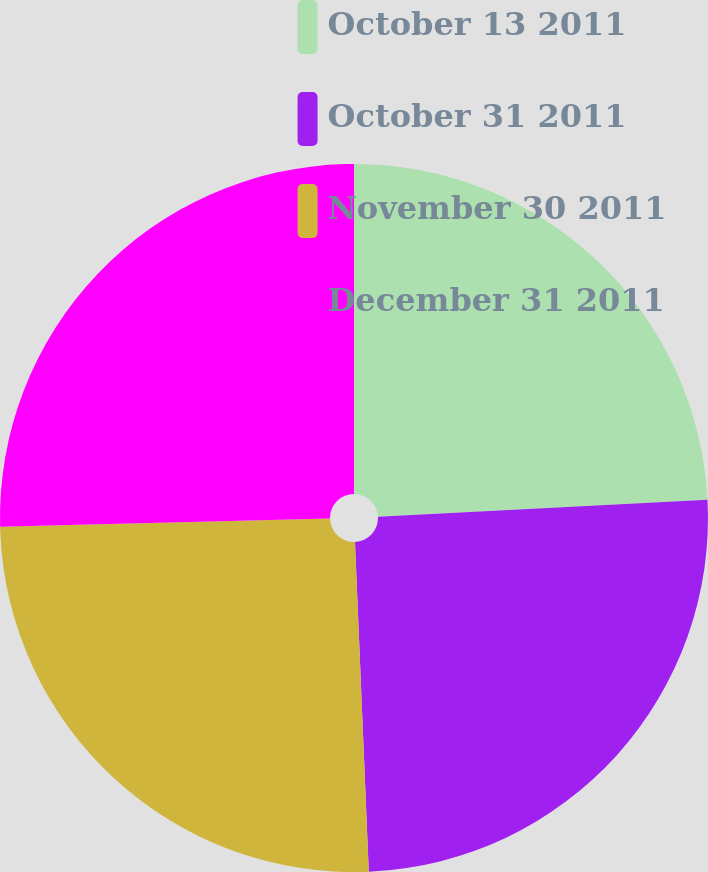Convert chart. <chart><loc_0><loc_0><loc_500><loc_500><pie_chart><fcel>October 13 2011<fcel>October 31 2011<fcel>November 30 2011<fcel>December 31 2011<nl><fcel>24.18%<fcel>25.15%<fcel>25.27%<fcel>25.39%<nl></chart> 